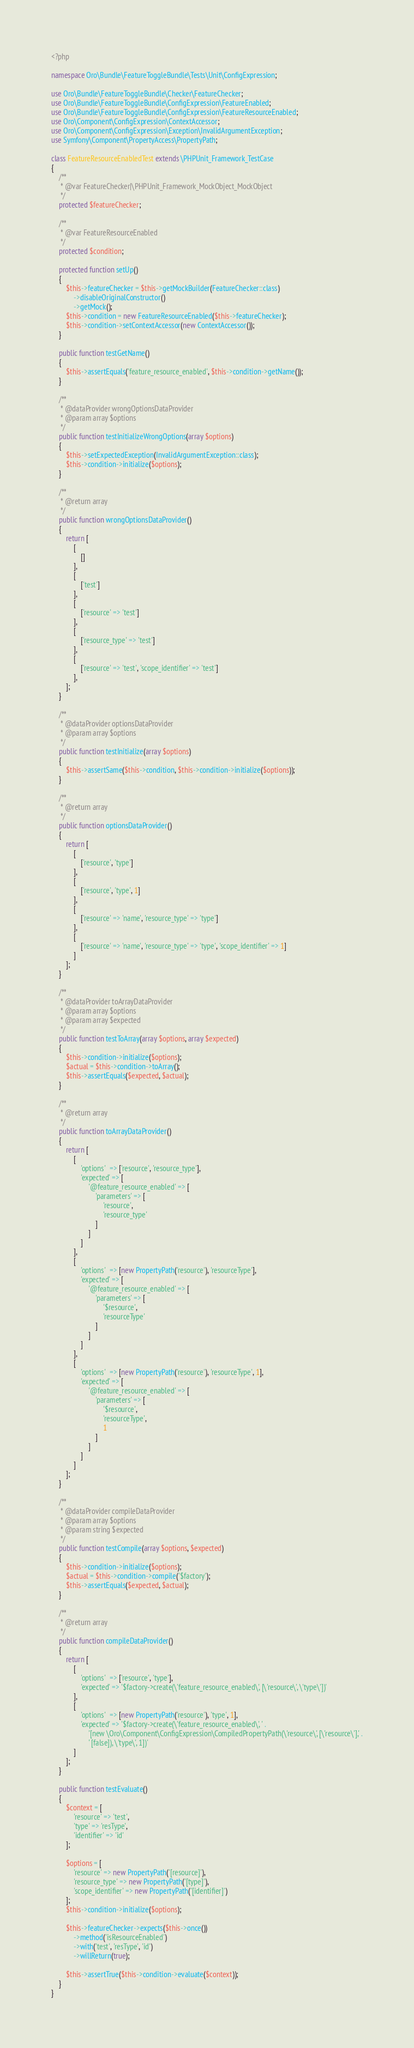Convert code to text. <code><loc_0><loc_0><loc_500><loc_500><_PHP_><?php

namespace Oro\Bundle\FeatureToggleBundle\Tests\Unit\ConfigExpression;

use Oro\Bundle\FeatureToggleBundle\Checker\FeatureChecker;
use Oro\Bundle\FeatureToggleBundle\ConfigExpression\FeatureEnabled;
use Oro\Bundle\FeatureToggleBundle\ConfigExpression\FeatureResourceEnabled;
use Oro\Component\ConfigExpression\ContextAccessor;
use Oro\Component\ConfigExpression\Exception\InvalidArgumentException;
use Symfony\Component\PropertyAccess\PropertyPath;

class FeatureResourceEnabledTest extends \PHPUnit_Framework_TestCase
{
    /**
     * @var FeatureChecker|\PHPUnit_Framework_MockObject_MockObject
     */
    protected $featureChecker;

    /**
     * @var FeatureResourceEnabled
     */
    protected $condition;

    protected function setUp()
    {
        $this->featureChecker = $this->getMockBuilder(FeatureChecker::class)
            ->disableOriginalConstructor()
            ->getMock();
        $this->condition = new FeatureResourceEnabled($this->featureChecker);
        $this->condition->setContextAccessor(new ContextAccessor());
    }

    public function testGetName()
    {
        $this->assertEquals('feature_resource_enabled', $this->condition->getName());
    }

    /**
     * @dataProvider wrongOptionsDataProvider
     * @param array $options
     */
    public function testInitializeWrongOptions(array $options)
    {
        $this->setExpectedException(InvalidArgumentException::class);
        $this->condition->initialize($options);
    }

    /**
     * @return array
     */
    public function wrongOptionsDataProvider()
    {
        return [
            [
                []
            ],
            [
                ['test']
            ],
            [
                ['resource' => 'test']
            ],
            [
                ['resource_type' => 'test']
            ],
            [
                ['resource' => 'test', 'scope_identifier' => 'test']
            ],
        ];
    }

    /**
     * @dataProvider optionsDataProvider
     * @param array $options
     */
    public function testInitialize(array $options)
    {
        $this->assertSame($this->condition, $this->condition->initialize($options));
    }

    /**
     * @return array
     */
    public function optionsDataProvider()
    {
        return [
            [
                ['resource', 'type']
            ],
            [
                ['resource', 'type', 1]
            ],
            [
                ['resource' => 'name', 'resource_type' => 'type']
            ],
            [
                ['resource' => 'name', 'resource_type' => 'type', 'scope_identifier' => 1]
            ]
        ];
    }

    /**
     * @dataProvider toArrayDataProvider
     * @param array $options
     * @param array $expected
     */
    public function testToArray(array $options, array $expected)
    {
        $this->condition->initialize($options);
        $actual = $this->condition->toArray();
        $this->assertEquals($expected, $actual);
    }

    /**
     * @return array
     */
    public function toArrayDataProvider()
    {
        return [
            [
                'options'  => ['resource', 'resource_type'],
                'expected' => [
                    '@feature_resource_enabled' => [
                        'parameters' => [
                            'resource',
                            'resource_type'
                        ]
                    ]
                ]
            ],
            [
                'options'  => [new PropertyPath('resource'), 'resourceType'],
                'expected' => [
                    '@feature_resource_enabled' => [
                        'parameters' => [
                            '$resource',
                            'resourceType'
                        ]
                    ]
                ]
            ],
            [
                'options'  => [new PropertyPath('resource'), 'resourceType', 1],
                'expected' => [
                    '@feature_resource_enabled' => [
                        'parameters' => [
                            '$resource',
                            'resourceType',
                            1
                        ]
                    ]
                ]
            ]
        ];
    }

    /**
     * @dataProvider compileDataProvider
     * @param array $options
     * @param string $expected
     */
    public function testCompile(array $options, $expected)
    {
        $this->condition->initialize($options);
        $actual = $this->condition->compile('$factory');
        $this->assertEquals($expected, $actual);
    }

    /**
     * @return array
     */
    public function compileDataProvider()
    {
        return [
            [
                'options'  => ['resource', 'type'],
                'expected' => '$factory->create(\'feature_resource_enabled\', [\'resource\', \'type\'])'
            ],
            [
                'options'  => [new PropertyPath('resource'), 'type', 1],
                'expected' => '$factory->create(\'feature_resource_enabled\', ' .
                    '[new \Oro\Component\ConfigExpression\CompiledPropertyPath(\'resource\', [\'resource\'],' .
                    ' [false]), \'type\', 1])'
            ]
        ];
    }

    public function testEvaluate()
    {
        $context = [
            'resource' => 'test',
            'type' => 'resType',
            'identifier' => 'id'
        ];

        $options = [
            'resource' => new PropertyPath('[resource]'),
            'resource_type' => new PropertyPath('[type]'),
            'scope_identifier' => new PropertyPath('[identifier]')
        ];
        $this->condition->initialize($options);

        $this->featureChecker->expects($this->once())
            ->method('isResourceEnabled')
            ->with('test', 'resType', 'id')
            ->willReturn(true);

        $this->assertTrue($this->condition->evaluate($context));
    }
}
</code> 